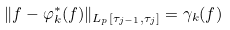Convert formula to latex. <formula><loc_0><loc_0><loc_500><loc_500>\| f - \varphi _ { k } ^ { * } ( f ) \| _ { L _ { p } [ \tau _ { j - 1 } , \tau _ { j } ] } = \gamma _ { k } ( f )</formula> 